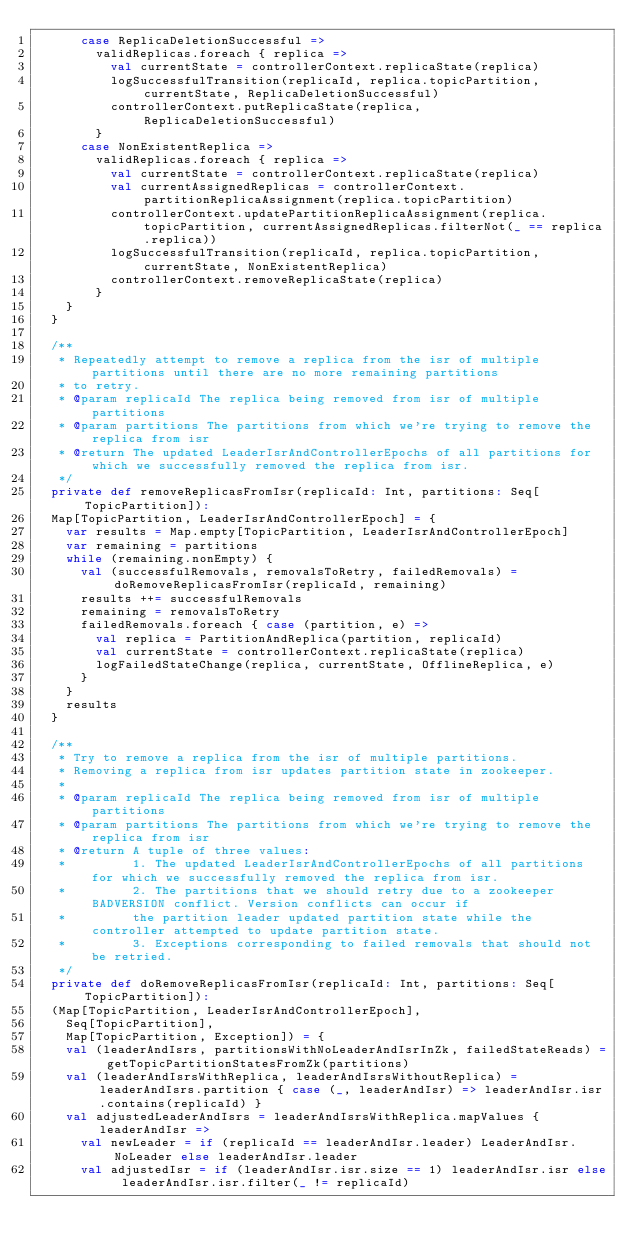Convert code to text. <code><loc_0><loc_0><loc_500><loc_500><_Scala_>      case ReplicaDeletionSuccessful =>
        validReplicas.foreach { replica =>
          val currentState = controllerContext.replicaState(replica)
          logSuccessfulTransition(replicaId, replica.topicPartition, currentState, ReplicaDeletionSuccessful)
          controllerContext.putReplicaState(replica, ReplicaDeletionSuccessful)
        }
      case NonExistentReplica =>
        validReplicas.foreach { replica =>
          val currentState = controllerContext.replicaState(replica)
          val currentAssignedReplicas = controllerContext.partitionReplicaAssignment(replica.topicPartition)
          controllerContext.updatePartitionReplicaAssignment(replica.topicPartition, currentAssignedReplicas.filterNot(_ == replica.replica))
          logSuccessfulTransition(replicaId, replica.topicPartition, currentState, NonExistentReplica)
          controllerContext.removeReplicaState(replica)
        }
    }
  }

  /**
   * Repeatedly attempt to remove a replica from the isr of multiple partitions until there are no more remaining partitions
   * to retry.
   * @param replicaId The replica being removed from isr of multiple partitions
   * @param partitions The partitions from which we're trying to remove the replica from isr
   * @return The updated LeaderIsrAndControllerEpochs of all partitions for which we successfully removed the replica from isr.
   */
  private def removeReplicasFromIsr(replicaId: Int, partitions: Seq[TopicPartition]):
  Map[TopicPartition, LeaderIsrAndControllerEpoch] = {
    var results = Map.empty[TopicPartition, LeaderIsrAndControllerEpoch]
    var remaining = partitions
    while (remaining.nonEmpty) {
      val (successfulRemovals, removalsToRetry, failedRemovals) = doRemoveReplicasFromIsr(replicaId, remaining)
      results ++= successfulRemovals
      remaining = removalsToRetry
      failedRemovals.foreach { case (partition, e) =>
        val replica = PartitionAndReplica(partition, replicaId)
        val currentState = controllerContext.replicaState(replica)
        logFailedStateChange(replica, currentState, OfflineReplica, e)
      }
    }
    results
  }

  /**
   * Try to remove a replica from the isr of multiple partitions.
   * Removing a replica from isr updates partition state in zookeeper.
   *
   * @param replicaId The replica being removed from isr of multiple partitions
   * @param partitions The partitions from which we're trying to remove the replica from isr
   * @return A tuple of three values:
   *         1. The updated LeaderIsrAndControllerEpochs of all partitions for which we successfully removed the replica from isr.
   *         2. The partitions that we should retry due to a zookeeper BADVERSION conflict. Version conflicts can occur if
   *         the partition leader updated partition state while the controller attempted to update partition state.
   *         3. Exceptions corresponding to failed removals that should not be retried.
   */
  private def doRemoveReplicasFromIsr(replicaId: Int, partitions: Seq[TopicPartition]):
  (Map[TopicPartition, LeaderIsrAndControllerEpoch],
    Seq[TopicPartition],
    Map[TopicPartition, Exception]) = {
    val (leaderAndIsrs, partitionsWithNoLeaderAndIsrInZk, failedStateReads) = getTopicPartitionStatesFromZk(partitions)
    val (leaderAndIsrsWithReplica, leaderAndIsrsWithoutReplica) = leaderAndIsrs.partition { case (_, leaderAndIsr) => leaderAndIsr.isr.contains(replicaId) }
    val adjustedLeaderAndIsrs = leaderAndIsrsWithReplica.mapValues { leaderAndIsr =>
      val newLeader = if (replicaId == leaderAndIsr.leader) LeaderAndIsr.NoLeader else leaderAndIsr.leader
      val adjustedIsr = if (leaderAndIsr.isr.size == 1) leaderAndIsr.isr else leaderAndIsr.isr.filter(_ != replicaId)</code> 